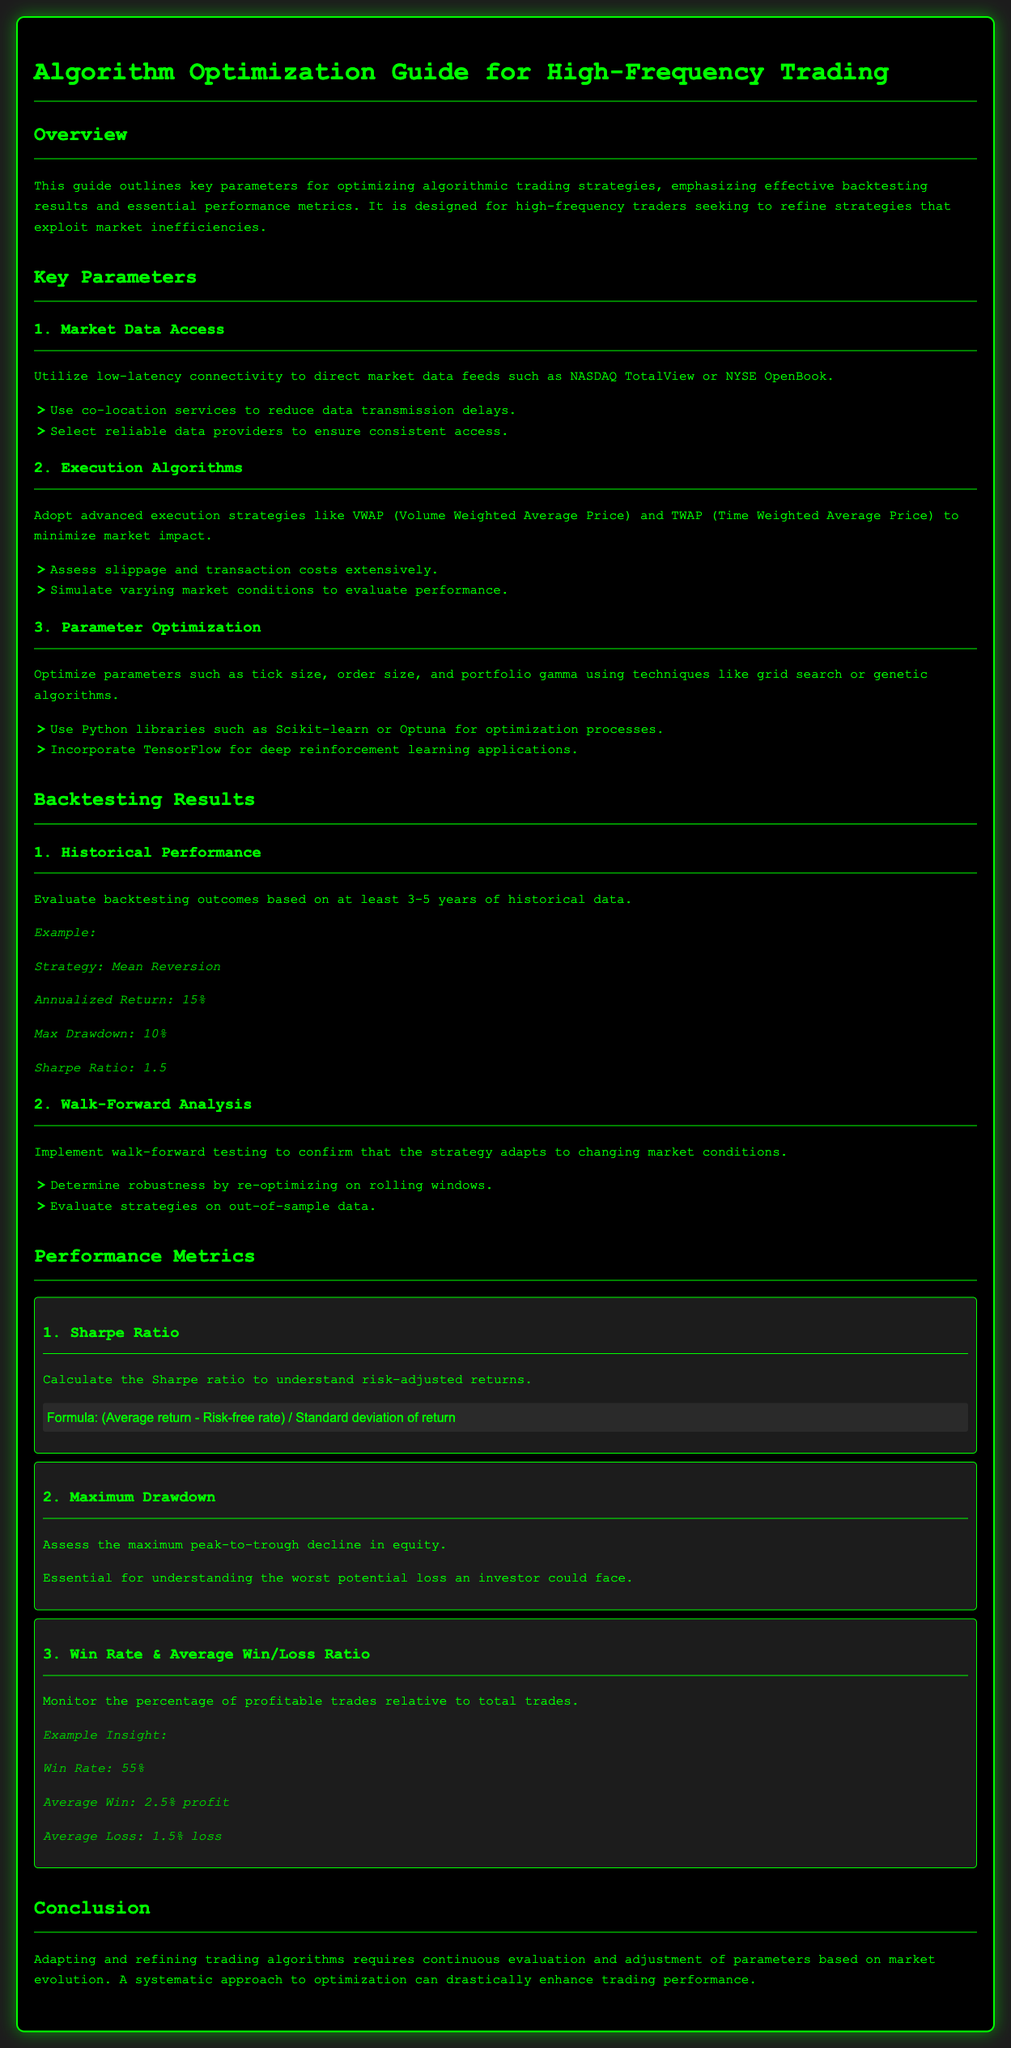What is the title of the guide? The title of the guide is mentioned at the top of the document.
Answer: Algorithm Optimization Guide for High-Frequency Trading What performance metric assesses risk-adjusted returns? This metric is specifically described in the Performance Metrics section of the document.
Answer: Sharpe Ratio What is the suggested period for analyzing historical data in backtesting? This information is specified in the Backtesting Results section, under Historical Performance.
Answer: 3-5 years What execution algorithms are recommended to minimize market impact? The document lists these algorithms in the Execution Algorithms subsection of Key Parameters.
Answer: VWAP and TWAP What is the formula for calculating the Sharpe Ratio? The formula is provided in the Performance Metrics section related to the Sharpe Ratio.
Answer: (Average return - Risk-free rate) / Standard deviation of return What does the maximum drawdown measure? This is explained in the context of Performance Metrics in the document.
Answer: Maximum peak-to-trough decline in equity What optimization techniques are mentioned for parameter optimization? The section on Parameter Optimization describes these techniques.
Answer: Grid search or genetic algorithms What is the win rate example provided in the document? This example insight can be found under the Win Rate & Average Win/Loss Ratio metric.
Answer: 55% What is emphasized for adapting and refining trading algorithms? The conclusion summarizes the key approach for improving trading strategies.
Answer: Continuous evaluation and adjustment 